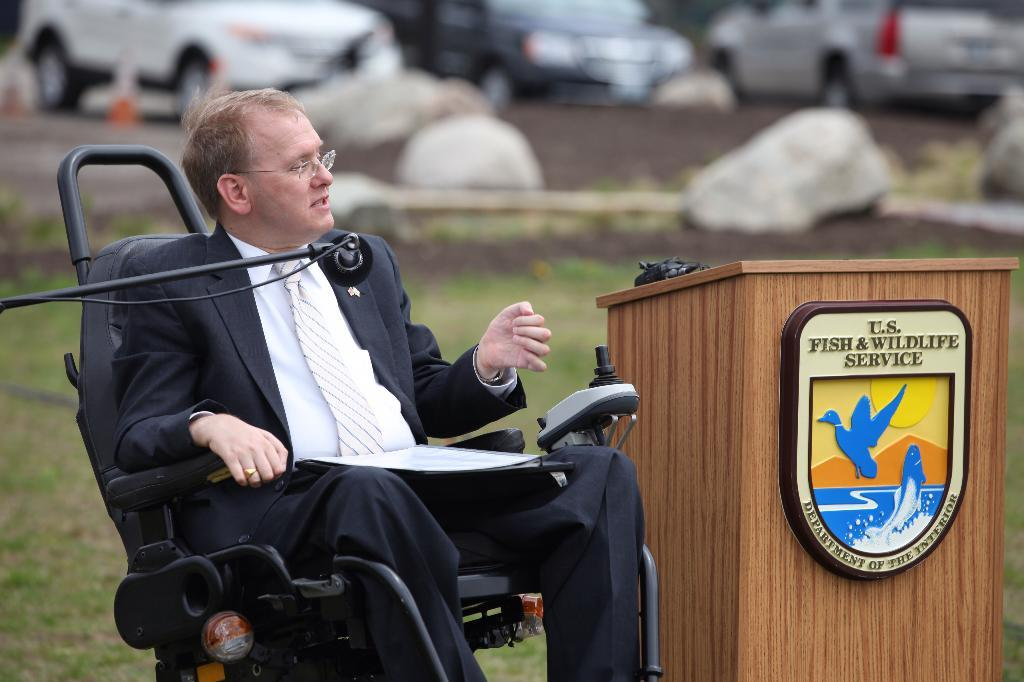Who is present in the image? There is a person in the image. What is the person wearing? The person is wearing a blazer. What is the person's position in the image? The person is sitting on a wheelchair. What object is in front of the person? There is a microphone in front of the person. What object is beside the person? There is a podium beside the person. What can be seen in the background of the image? Many cars are visible in the background of the image. What type of swing can be seen in the image? There is no swing present in the image. What is the weight of the rat in the image? There is no rat present in the image. 